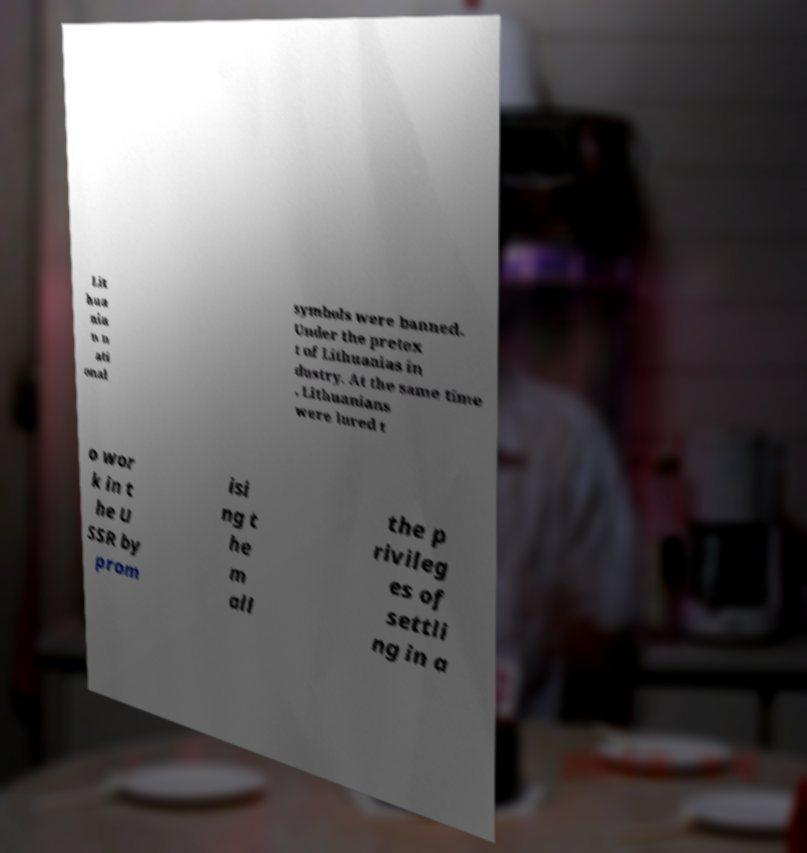There's text embedded in this image that I need extracted. Can you transcribe it verbatim? Lit hua nia n n ati onal symbols were banned. Under the pretex t of Lithuanias in dustry. At the same time , Lithuanians were lured t o wor k in t he U SSR by prom isi ng t he m all the p rivileg es of settli ng in a 